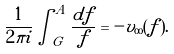<formula> <loc_0><loc_0><loc_500><loc_500>\frac { 1 } { 2 \pi i } \int _ { G } ^ { A } \frac { d f } { f } = - v _ { \infty } ( f ) .</formula> 